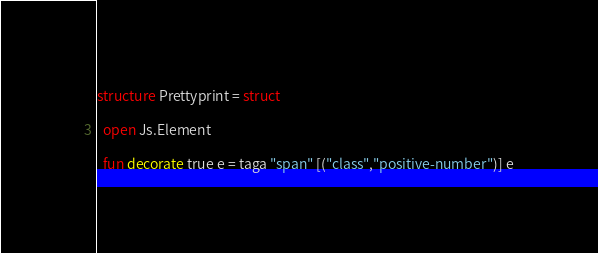Convert code to text. <code><loc_0><loc_0><loc_500><loc_500><_SML_>structure Prettyprint = struct

  open Js.Element

  fun decorate true e = taga "span" [("class","positive-number")] e</code> 